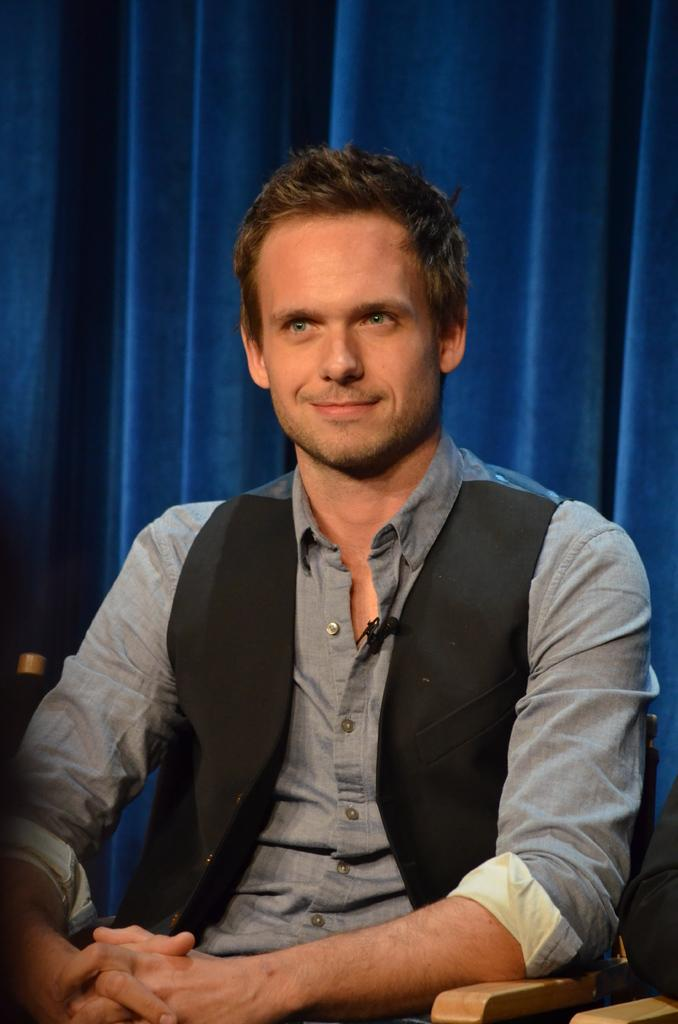What is the person in the image doing? The person is sitting in the image. What is the person wearing? The person is wearing a gray and black color dress. What can be seen in the background of the image? There are blue curtains in the background of the image. What type of division is being taught in the image? There is no indication of any division or teaching activity in the image. 